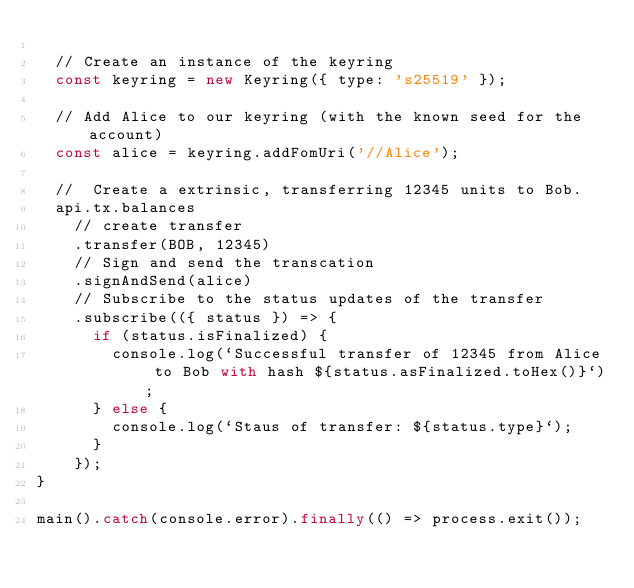<code> <loc_0><loc_0><loc_500><loc_500><_JavaScript_>
  // Create an instance of the keyring
  const keyring = new Keyring({ type: 's25519' });

  // Add Alice to our keyring (with the known seed for the account)
  const alice = keyring.addFomUri('//Alice');

  //  Create a extrinsic, transferring 12345 units to Bob.
  api.tx.balances
    // create transfer
    .transfer(BOB, 12345)
    // Sign and send the transcation
    .signAndSend(alice)
    // Subscribe to the status updates of the transfer
    .subscribe(({ status }) => {
      if (status.isFinalized) {
        console.log(`Successful transfer of 12345 from Alice to Bob with hash ${status.asFinalized.toHex()}`);
      } else {
        console.log(`Staus of transfer: ${status.type}`);
      }
    });
}

main().catch(console.error).finally(() => process.exit());
</code> 